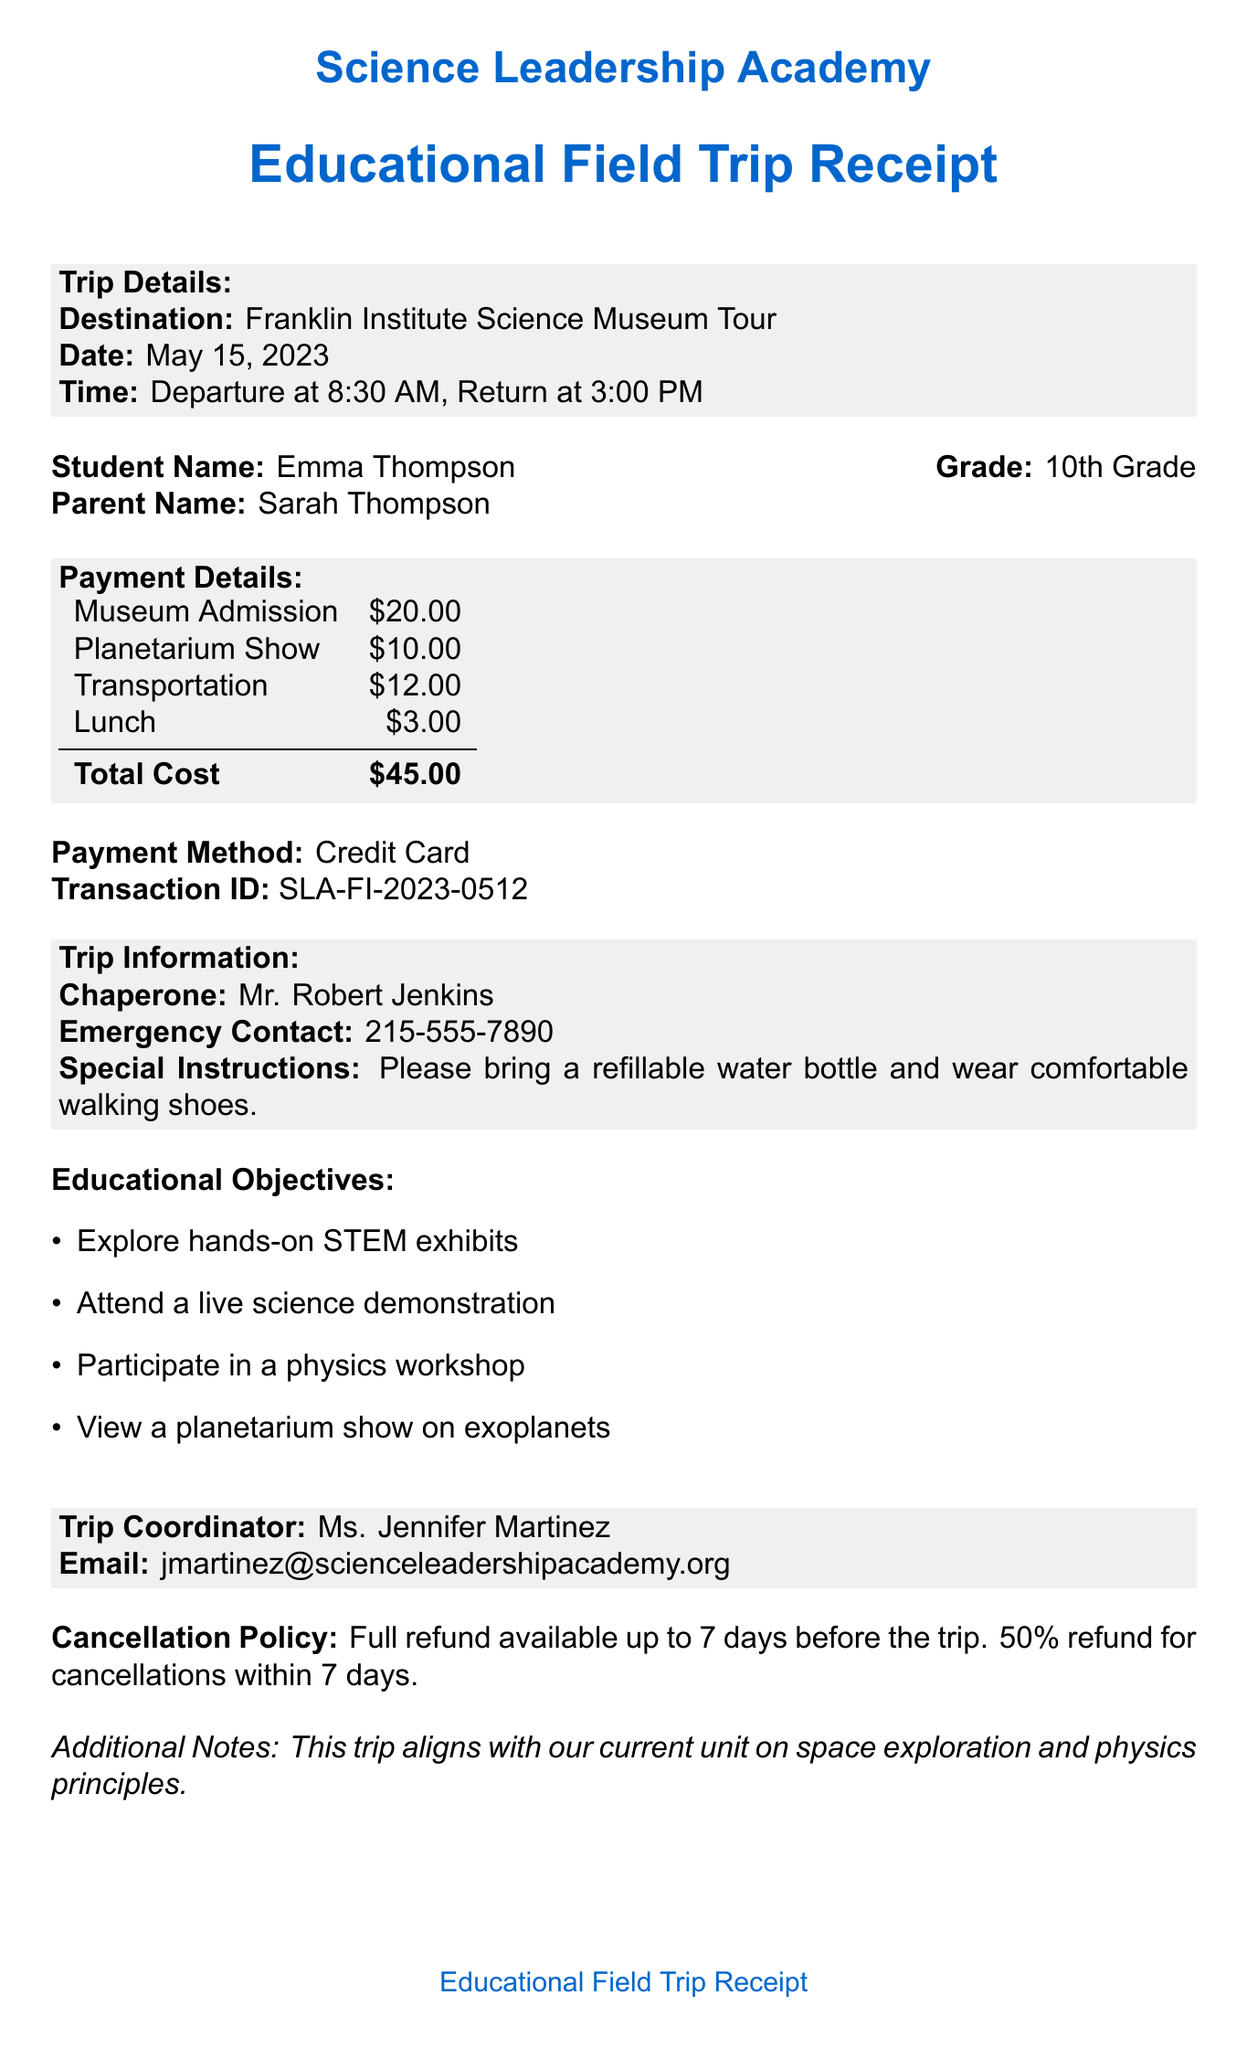What is the name of the student? The document specifies the name of the student participating in the trip, which is Emma Thompson.
Answer: Emma Thompson What is the total cost of the trip? The total cost of the trip is explicitly mentioned in the payment details section, which is $45.00.
Answer: $45.00 What date is the field trip scheduled for? The date for the trip is clearly stated in the trip details section as May 15, 2023.
Answer: May 15, 2023 Who is the trip coordinator? The document contains a section with the name of the trip coordinator, which is Ms. Jennifer Martinez.
Answer: Ms. Jennifer Martinez What time does the trip depart? The departure time for the trip is found in the trip details section, which is stated as 8:30 AM.
Answer: 8:30 AM What is included in the payment breakdown for lunch? The document lists the amount allocated for lunch in the payment breakdown, which is $3.00.
Answer: $3.00 What is the cancellation policy for the trip? The cancellation policy details are included, stating full refund and percentage for cancellations made before or after a specific time.
Answer: Full refund available up to 7 days before the trip. 50% refund for cancellations within 7 days What is a special instruction for the trip? The document specifies a special instruction related to preparation for the trip, which is to bring a refillable water bottle and wear comfortable walking shoes.
Answer: Please bring a refillable water bottle and wear comfortable walking shoes What is the emergency contact number? The document provides an emergency contact number that is intended for use during the trip, indicated as 215-555-7890.
Answer: 215-555-7890 